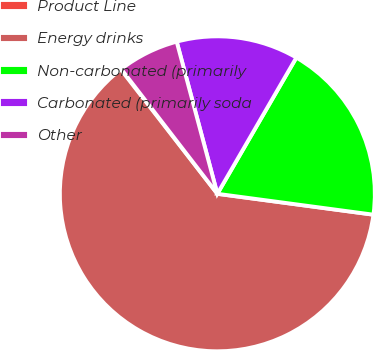<chart> <loc_0><loc_0><loc_500><loc_500><pie_chart><fcel>Product Line<fcel>Energy drinks<fcel>Non-carbonated (primarily<fcel>Carbonated (primarily soda<fcel>Other<nl><fcel>0.06%<fcel>62.37%<fcel>18.75%<fcel>12.52%<fcel>6.29%<nl></chart> 